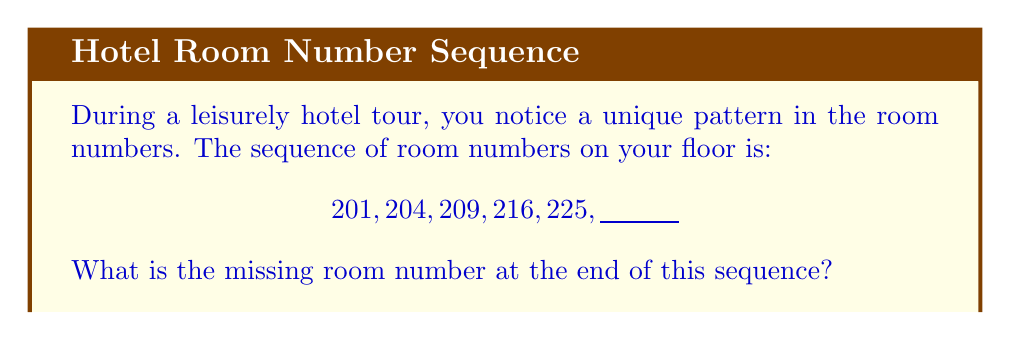Give your solution to this math problem. Let's approach this step-by-step:

1) First, let's look at the differences between consecutive terms:
   201 to 204: difference of 3
   204 to 209: difference of 5
   209 to 216: difference of 7
   216 to 225: difference of 9

2) We can see that the differences themselves form a sequence: 3, 5, 7, 9

3) This sequence of differences is an arithmetic sequence with a common difference of 2.

4) Following this pattern, the next difference should be 11.

5) So, to find the next term in the original sequence, we add 11 to 225:

   $225 + 11 = 236$

6) We can verify this by writing out the full sequence with the differences:

   $$201 \xrightarrow{+3} 204 \xrightarrow{+5} 209 \xrightarrow{+7} 216 \xrightarrow{+9} 225 \xrightarrow{+11} 236$$

Therefore, the missing room number at the end of the sequence is 236.
Answer: 236 